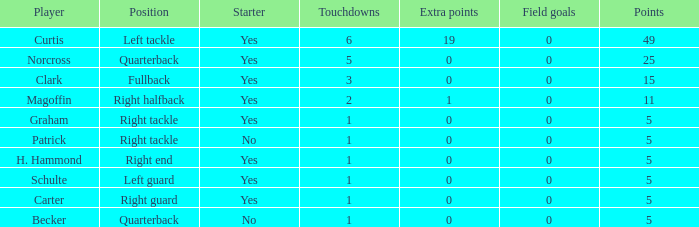Specify the greatest amount of touchdowns for norcross. 5.0. 